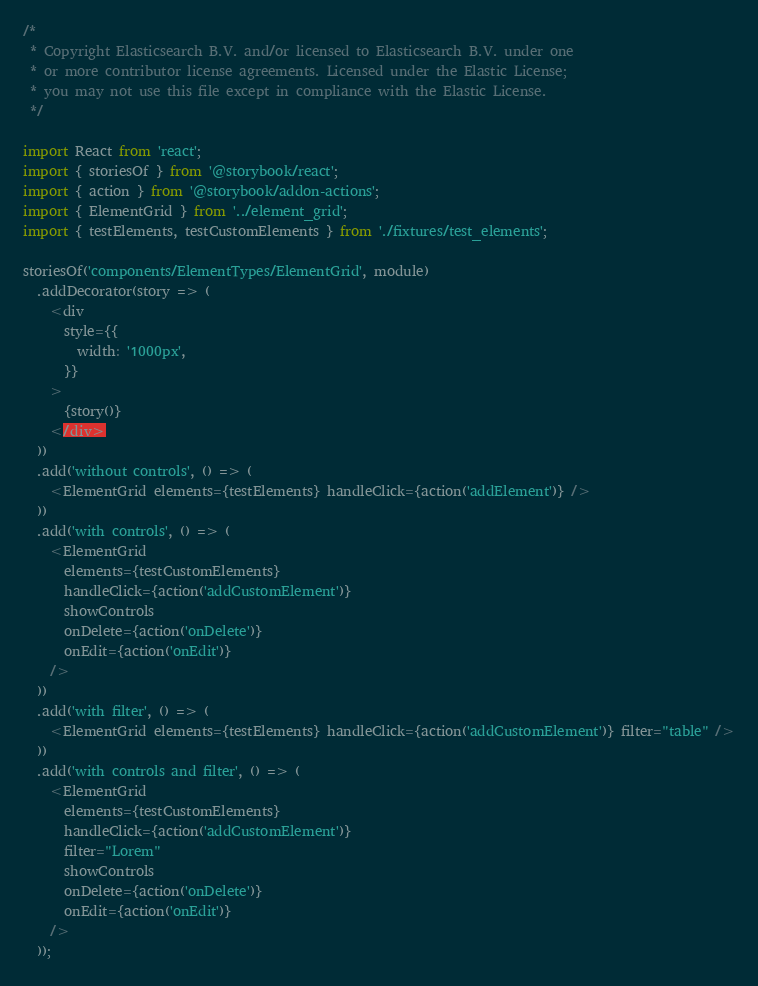Convert code to text. <code><loc_0><loc_0><loc_500><loc_500><_TypeScript_>/*
 * Copyright Elasticsearch B.V. and/or licensed to Elasticsearch B.V. under one
 * or more contributor license agreements. Licensed under the Elastic License;
 * you may not use this file except in compliance with the Elastic License.
 */

import React from 'react';
import { storiesOf } from '@storybook/react';
import { action } from '@storybook/addon-actions';
import { ElementGrid } from '../element_grid';
import { testElements, testCustomElements } from './fixtures/test_elements';

storiesOf('components/ElementTypes/ElementGrid', module)
  .addDecorator(story => (
    <div
      style={{
        width: '1000px',
      }}
    >
      {story()}
    </div>
  ))
  .add('without controls', () => (
    <ElementGrid elements={testElements} handleClick={action('addElement')} />
  ))
  .add('with controls', () => (
    <ElementGrid
      elements={testCustomElements}
      handleClick={action('addCustomElement')}
      showControls
      onDelete={action('onDelete')}
      onEdit={action('onEdit')}
    />
  ))
  .add('with filter', () => (
    <ElementGrid elements={testElements} handleClick={action('addCustomElement')} filter="table" />
  ))
  .add('with controls and filter', () => (
    <ElementGrid
      elements={testCustomElements}
      handleClick={action('addCustomElement')}
      filter="Lorem"
      showControls
      onDelete={action('onDelete')}
      onEdit={action('onEdit')}
    />
  ));
</code> 